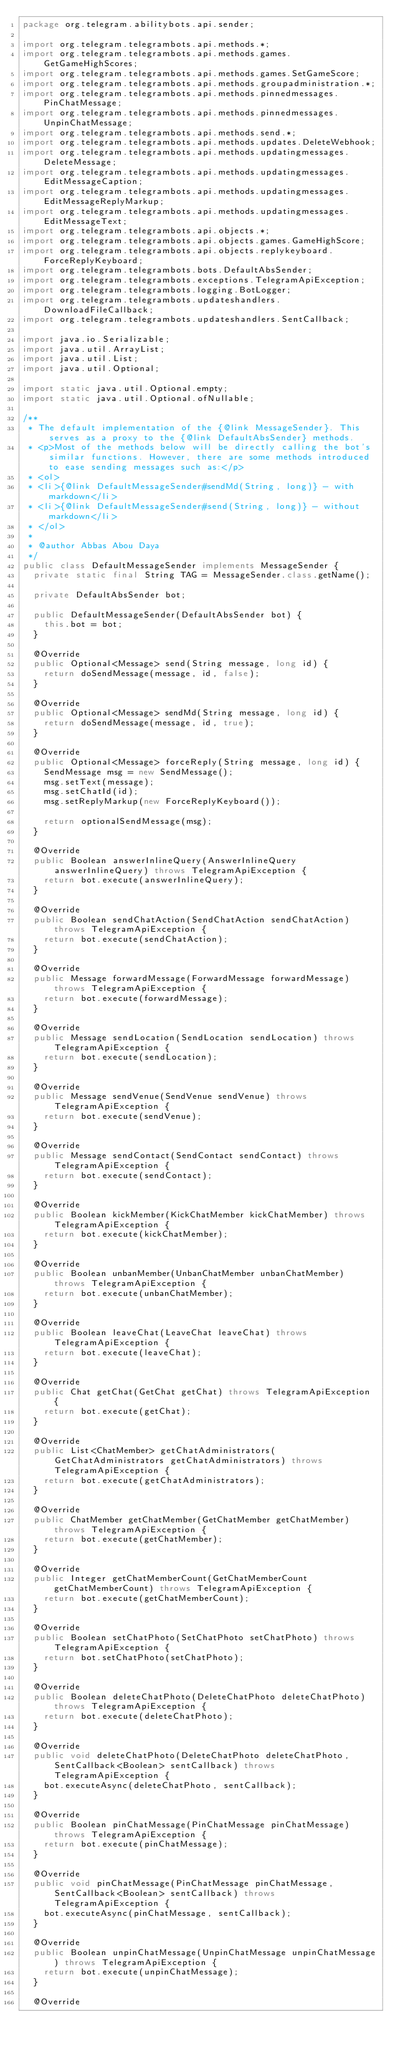<code> <loc_0><loc_0><loc_500><loc_500><_Java_>package org.telegram.abilitybots.api.sender;

import org.telegram.telegrambots.api.methods.*;
import org.telegram.telegrambots.api.methods.games.GetGameHighScores;
import org.telegram.telegrambots.api.methods.games.SetGameScore;
import org.telegram.telegrambots.api.methods.groupadministration.*;
import org.telegram.telegrambots.api.methods.pinnedmessages.PinChatMessage;
import org.telegram.telegrambots.api.methods.pinnedmessages.UnpinChatMessage;
import org.telegram.telegrambots.api.methods.send.*;
import org.telegram.telegrambots.api.methods.updates.DeleteWebhook;
import org.telegram.telegrambots.api.methods.updatingmessages.DeleteMessage;
import org.telegram.telegrambots.api.methods.updatingmessages.EditMessageCaption;
import org.telegram.telegrambots.api.methods.updatingmessages.EditMessageReplyMarkup;
import org.telegram.telegrambots.api.methods.updatingmessages.EditMessageText;
import org.telegram.telegrambots.api.objects.*;
import org.telegram.telegrambots.api.objects.games.GameHighScore;
import org.telegram.telegrambots.api.objects.replykeyboard.ForceReplyKeyboard;
import org.telegram.telegrambots.bots.DefaultAbsSender;
import org.telegram.telegrambots.exceptions.TelegramApiException;
import org.telegram.telegrambots.logging.BotLogger;
import org.telegram.telegrambots.updateshandlers.DownloadFileCallback;
import org.telegram.telegrambots.updateshandlers.SentCallback;

import java.io.Serializable;
import java.util.ArrayList;
import java.util.List;
import java.util.Optional;

import static java.util.Optional.empty;
import static java.util.Optional.ofNullable;

/**
 * The default implementation of the {@link MessageSender}. This serves as a proxy to the {@link DefaultAbsSender} methods.
 * <p>Most of the methods below will be directly calling the bot's similar functions. However, there are some methods introduced to ease sending messages such as:</p>
 * <ol>
 * <li>{@link DefaultMessageSender#sendMd(String, long)} - with markdown</li>
 * <li>{@link DefaultMessageSender#send(String, long)} - without markdown</li>
 * </ol>
 *
 * @author Abbas Abou Daya
 */
public class DefaultMessageSender implements MessageSender {
  private static final String TAG = MessageSender.class.getName();

  private DefaultAbsSender bot;

  public DefaultMessageSender(DefaultAbsSender bot) {
    this.bot = bot;
  }

  @Override
  public Optional<Message> send(String message, long id) {
    return doSendMessage(message, id, false);
  }

  @Override
  public Optional<Message> sendMd(String message, long id) {
    return doSendMessage(message, id, true);
  }

  @Override
  public Optional<Message> forceReply(String message, long id) {
    SendMessage msg = new SendMessage();
    msg.setText(message);
    msg.setChatId(id);
    msg.setReplyMarkup(new ForceReplyKeyboard());

    return optionalSendMessage(msg);
  }

  @Override
  public Boolean answerInlineQuery(AnswerInlineQuery answerInlineQuery) throws TelegramApiException {
    return bot.execute(answerInlineQuery);
  }

  @Override
  public Boolean sendChatAction(SendChatAction sendChatAction) throws TelegramApiException {
    return bot.execute(sendChatAction);
  }

  @Override
  public Message forwardMessage(ForwardMessage forwardMessage) throws TelegramApiException {
    return bot.execute(forwardMessage);
  }

  @Override
  public Message sendLocation(SendLocation sendLocation) throws TelegramApiException {
    return bot.execute(sendLocation);
  }

  @Override
  public Message sendVenue(SendVenue sendVenue) throws TelegramApiException {
    return bot.execute(sendVenue);
  }

  @Override
  public Message sendContact(SendContact sendContact) throws TelegramApiException {
    return bot.execute(sendContact);
  }

  @Override
  public Boolean kickMember(KickChatMember kickChatMember) throws TelegramApiException {
    return bot.execute(kickChatMember);
  }

  @Override
  public Boolean unbanMember(UnbanChatMember unbanChatMember) throws TelegramApiException {
    return bot.execute(unbanChatMember);
  }

  @Override
  public Boolean leaveChat(LeaveChat leaveChat) throws TelegramApiException {
    return bot.execute(leaveChat);
  }

  @Override
  public Chat getChat(GetChat getChat) throws TelegramApiException {
    return bot.execute(getChat);
  }

  @Override
  public List<ChatMember> getChatAdministrators(GetChatAdministrators getChatAdministrators) throws TelegramApiException {
    return bot.execute(getChatAdministrators);
  }

  @Override
  public ChatMember getChatMember(GetChatMember getChatMember) throws TelegramApiException {
    return bot.execute(getChatMember);
  }

  @Override
  public Integer getChatMemberCount(GetChatMemberCount getChatMemberCount) throws TelegramApiException {
    return bot.execute(getChatMemberCount);
  }

  @Override
  public Boolean setChatPhoto(SetChatPhoto setChatPhoto) throws TelegramApiException {
    return bot.setChatPhoto(setChatPhoto);
  }

  @Override
  public Boolean deleteChatPhoto(DeleteChatPhoto deleteChatPhoto) throws TelegramApiException {
    return bot.execute(deleteChatPhoto);
  }

  @Override
  public void deleteChatPhoto(DeleteChatPhoto deleteChatPhoto, SentCallback<Boolean> sentCallback) throws TelegramApiException {
    bot.executeAsync(deleteChatPhoto, sentCallback);
  }

  @Override
  public Boolean pinChatMessage(PinChatMessage pinChatMessage) throws TelegramApiException {
    return bot.execute(pinChatMessage);
  }

  @Override
  public void pinChatMessage(PinChatMessage pinChatMessage, SentCallback<Boolean> sentCallback) throws TelegramApiException {
    bot.executeAsync(pinChatMessage, sentCallback);
  }

  @Override
  public Boolean unpinChatMessage(UnpinChatMessage unpinChatMessage) throws TelegramApiException {
    return bot.execute(unpinChatMessage);
  }

  @Override</code> 